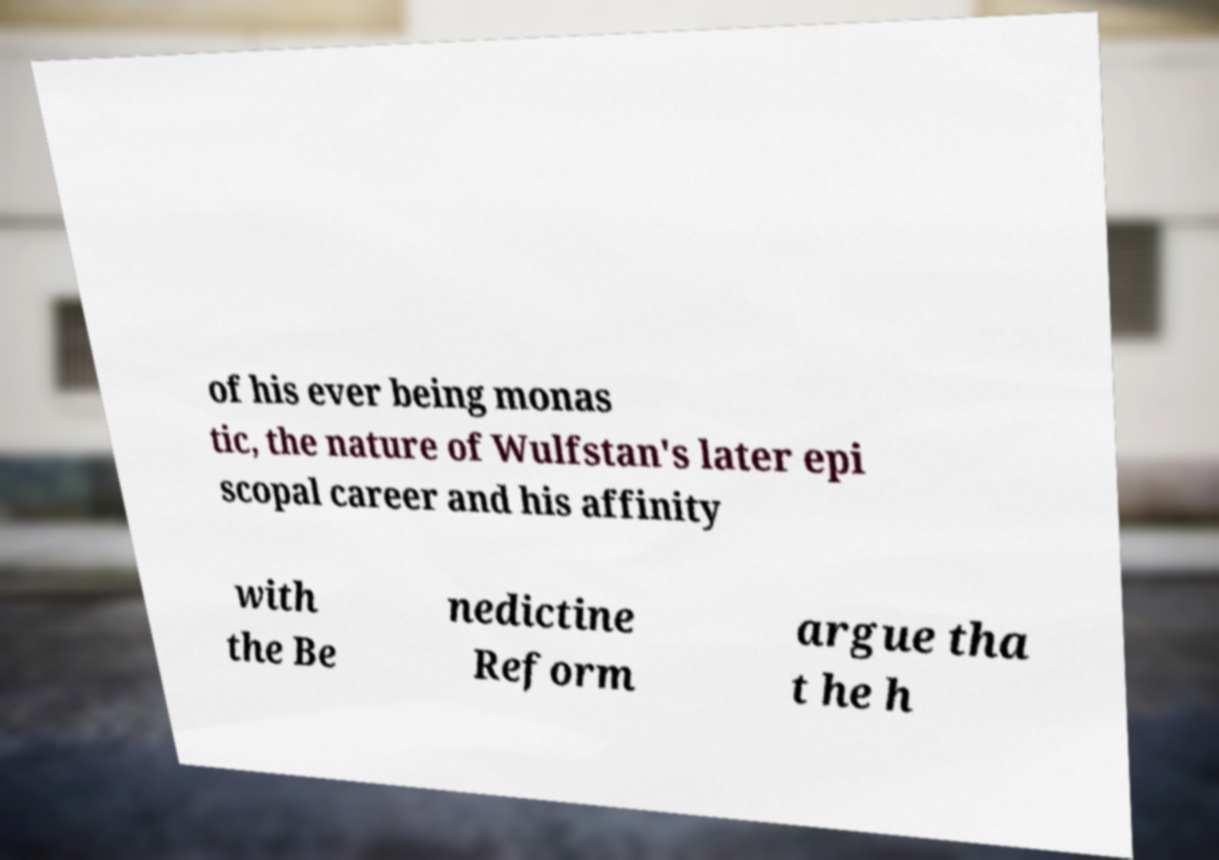Please identify and transcribe the text found in this image. of his ever being monas tic, the nature of Wulfstan's later epi scopal career and his affinity with the Be nedictine Reform argue tha t he h 